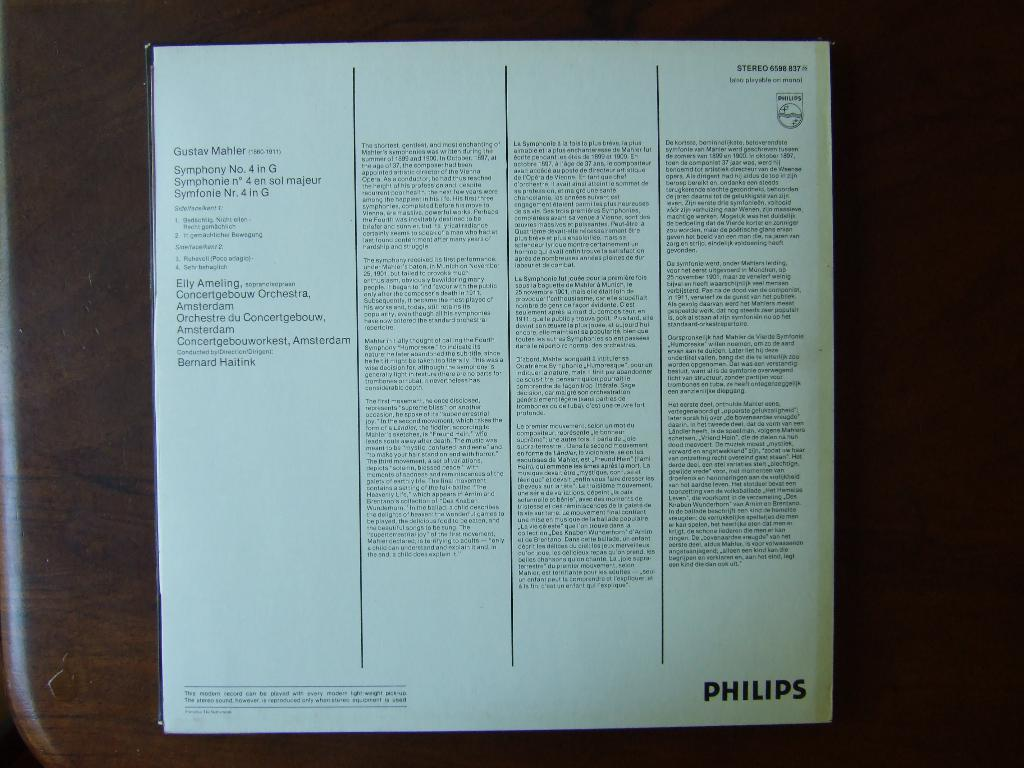<image>
Share a concise interpretation of the image provided. Gustav Mahler Philips stereo and biography back cover. 